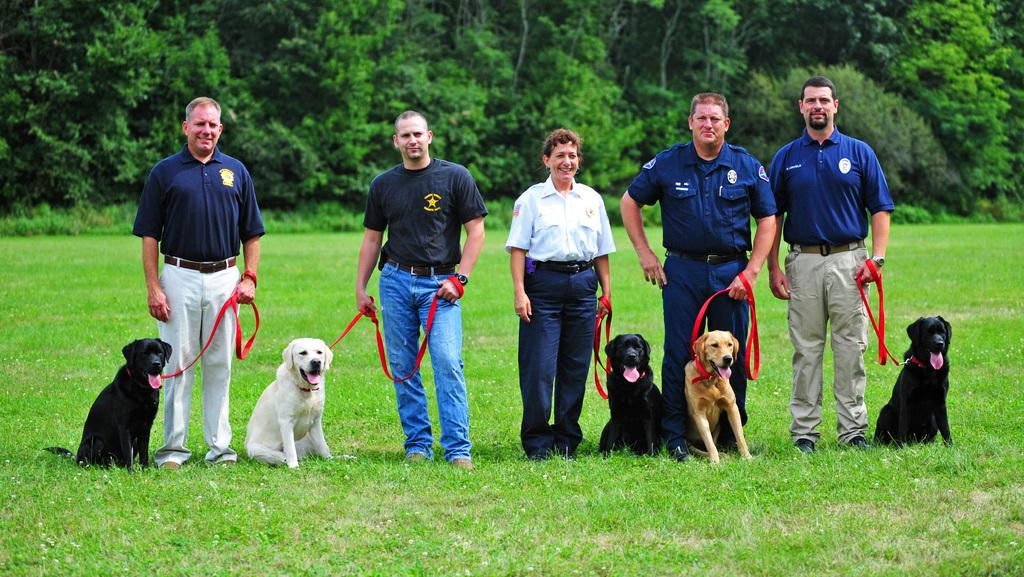How many people are in the image? There are five people in the image, including four men and one woman. What are the people doing in the image? Each person is holding a dog in the image. Where are the people standing? The people are standing on the grass in the image. What can be seen in the background of the image? There are many trees in the background of the image. How many children are playing in the war depicted in the image? There is no war or children present in the image; it features five people holding dogs on the grass. Can you tell me what type of horse is running in the background of the image? There is no horse present in the image; it features trees in the background. 